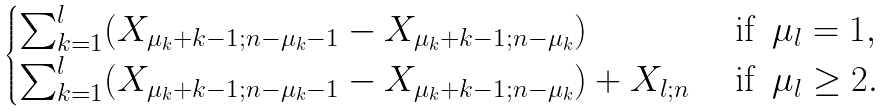Convert formula to latex. <formula><loc_0><loc_0><loc_500><loc_500>\begin{cases} \sum _ { k = 1 } ^ { l } ( X _ { \mu _ { k } + k - 1 ; n - \mu _ { k } - 1 } - X _ { \mu _ { k } + k - 1 ; n - \mu _ { k } } ) & \text { if } \, \mu _ { l } = 1 , \\ \sum _ { k = 1 } ^ { l } ( X _ { \mu _ { k } + k - 1 ; n - \mu _ { k } - 1 } - X _ { \mu _ { k } + k - 1 ; n - \mu _ { k } } ) + X _ { l ; n } & \text { if } \, \mu _ { l } \geq 2 . \end{cases}</formula> 